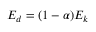<formula> <loc_0><loc_0><loc_500><loc_500>E _ { d } = ( 1 - \alpha ) E _ { k }</formula> 